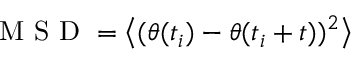Convert formula to latex. <formula><loc_0><loc_0><loc_500><loc_500>M S D = \left < ( \theta ( t _ { i } ) - \theta ( t _ { i } + t ) ) ^ { 2 } \right ></formula> 